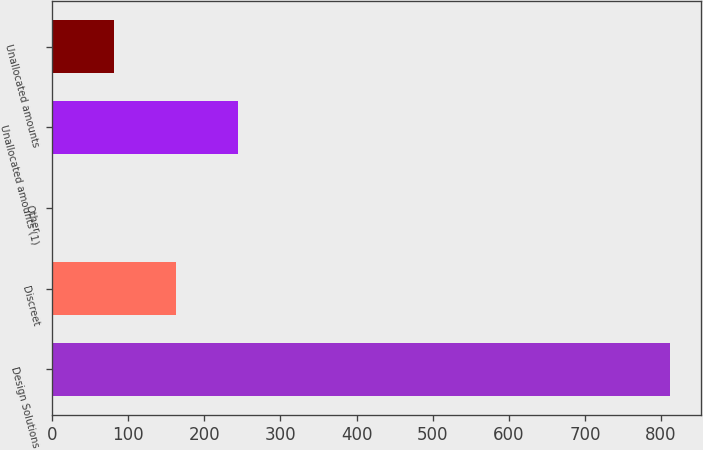Convert chart to OTSL. <chart><loc_0><loc_0><loc_500><loc_500><bar_chart><fcel>Design Solutions<fcel>Discreet<fcel>Other<fcel>Unallocated amounts (1)<fcel>Unallocated amounts<nl><fcel>811.7<fcel>162.58<fcel>0.3<fcel>243.72<fcel>81.44<nl></chart> 